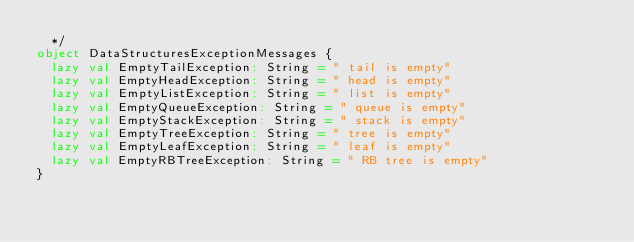<code> <loc_0><loc_0><loc_500><loc_500><_Scala_>  */
object DataStructuresExceptionMessages {
  lazy val EmptyTailException: String = " tail is empty"
  lazy val EmptyHeadException: String = " head is empty"
  lazy val EmptyListException: String = " list is empty"
  lazy val EmptyQueueException: String = " queue is empty"
  lazy val EmptyStackException: String = " stack is empty"
  lazy val EmptyTreeException: String = " tree is empty"
  lazy val EmptyLeafException: String = " leaf is empty"
  lazy val EmptyRBTreeException: String = " RB tree is empty"
}
</code> 